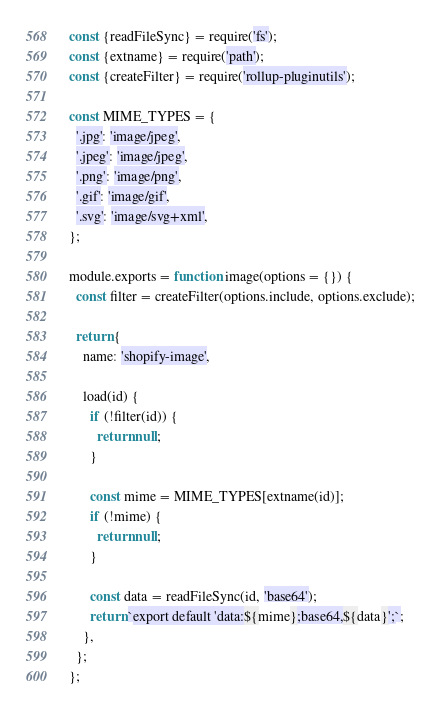Convert code to text. <code><loc_0><loc_0><loc_500><loc_500><_JavaScript_>const {readFileSync} = require('fs');
const {extname} = require('path');
const {createFilter} = require('rollup-pluginutils');

const MIME_TYPES = {
  '.jpg': 'image/jpeg',
  '.jpeg': 'image/jpeg',
  '.png': 'image/png',
  '.gif': 'image/gif',
  '.svg': 'image/svg+xml',
};

module.exports = function image(options = {}) {
  const filter = createFilter(options.include, options.exclude);

  return {
    name: 'shopify-image',

    load(id) {
      if (!filter(id)) {
        return null;
      }

      const mime = MIME_TYPES[extname(id)];
      if (!mime) {
        return null;
      }

      const data = readFileSync(id, 'base64');
      return `export default 'data:${mime};base64,${data}';`;
    },
  };
};
</code> 